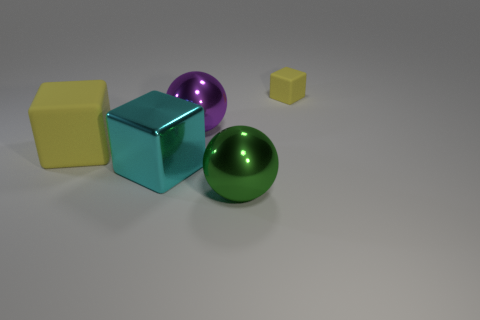Subtract all red balls. How many yellow cubes are left? 2 Subtract all yellow cubes. How many cubes are left? 1 Add 5 small cyan shiny objects. How many objects exist? 10 Subtract all spheres. How many objects are left? 3 Subtract all red cubes. Subtract all brown balls. How many cubes are left? 3 Add 3 cyan cubes. How many cyan cubes are left? 4 Add 5 large brown metallic spheres. How many large brown metallic spheres exist? 5 Subtract 0 green cubes. How many objects are left? 5 Subtract all tiny red rubber cylinders. Subtract all big balls. How many objects are left? 3 